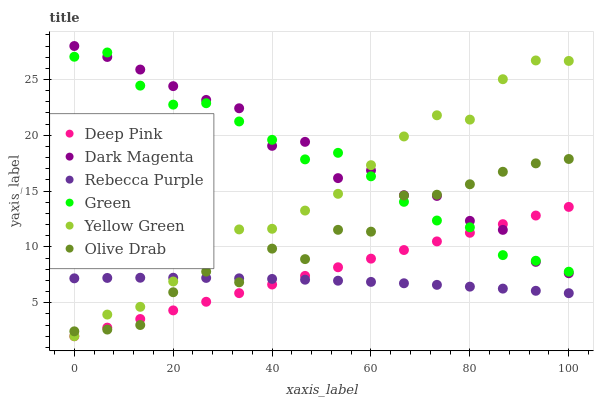Does Rebecca Purple have the minimum area under the curve?
Answer yes or no. Yes. Does Dark Magenta have the maximum area under the curve?
Answer yes or no. Yes. Does Yellow Green have the minimum area under the curve?
Answer yes or no. No. Does Yellow Green have the maximum area under the curve?
Answer yes or no. No. Is Deep Pink the smoothest?
Answer yes or no. Yes. Is Olive Drab the roughest?
Answer yes or no. Yes. Is Yellow Green the smoothest?
Answer yes or no. No. Is Yellow Green the roughest?
Answer yes or no. No. Does Deep Pink have the lowest value?
Answer yes or no. Yes. Does Green have the lowest value?
Answer yes or no. No. Does Dark Magenta have the highest value?
Answer yes or no. Yes. Does Yellow Green have the highest value?
Answer yes or no. No. Is Rebecca Purple less than Green?
Answer yes or no. Yes. Is Green greater than Rebecca Purple?
Answer yes or no. Yes. Does Yellow Green intersect Dark Magenta?
Answer yes or no. Yes. Is Yellow Green less than Dark Magenta?
Answer yes or no. No. Is Yellow Green greater than Dark Magenta?
Answer yes or no. No. Does Rebecca Purple intersect Green?
Answer yes or no. No. 